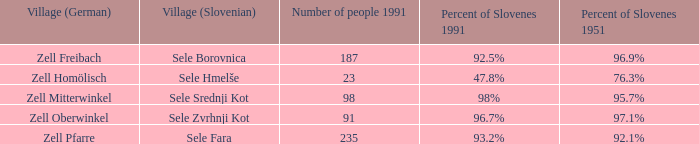Provide me with the names of all the villages (German) that has 76.3% of Slovenes in 1951. Zell Homölisch. Can you give me this table as a dict? {'header': ['Village (German)', 'Village (Slovenian)', 'Number of people 1991', 'Percent of Slovenes 1991', 'Percent of Slovenes 1951'], 'rows': [['Zell Freibach', 'Sele Borovnica', '187', '92.5%', '96.9%'], ['Zell Homölisch', 'Sele Hmelše', '23', '47.8%', '76.3%'], ['Zell Mitterwinkel', 'Sele Srednji Kot', '98', '98%', '95.7%'], ['Zell Oberwinkel', 'Sele Zvrhnji Kot', '91', '96.7%', '97.1%'], ['Zell Pfarre', 'Sele Fara', '235', '93.2%', '92.1%']]} 